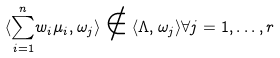Convert formula to latex. <formula><loc_0><loc_0><loc_500><loc_500>\langle { \sum _ { i = 1 } ^ { n } } w _ { i } \mu _ { i } , \omega _ { j } \rangle \notin \langle \Lambda , \omega _ { j } \rangle \forall j = 1 , \dots , r</formula> 